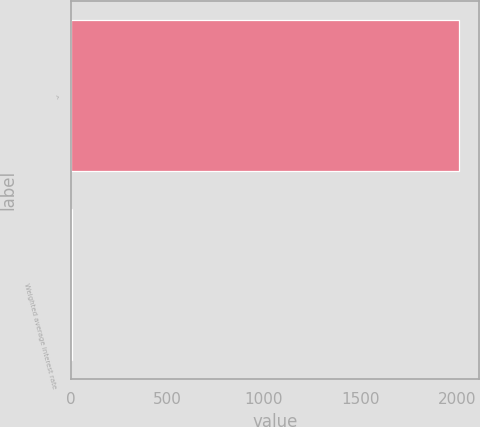Convert chart. <chart><loc_0><loc_0><loc_500><loc_500><bar_chart><fcel>^<fcel>Weighted average interest rate<nl><fcel>2010<fcel>4.76<nl></chart> 